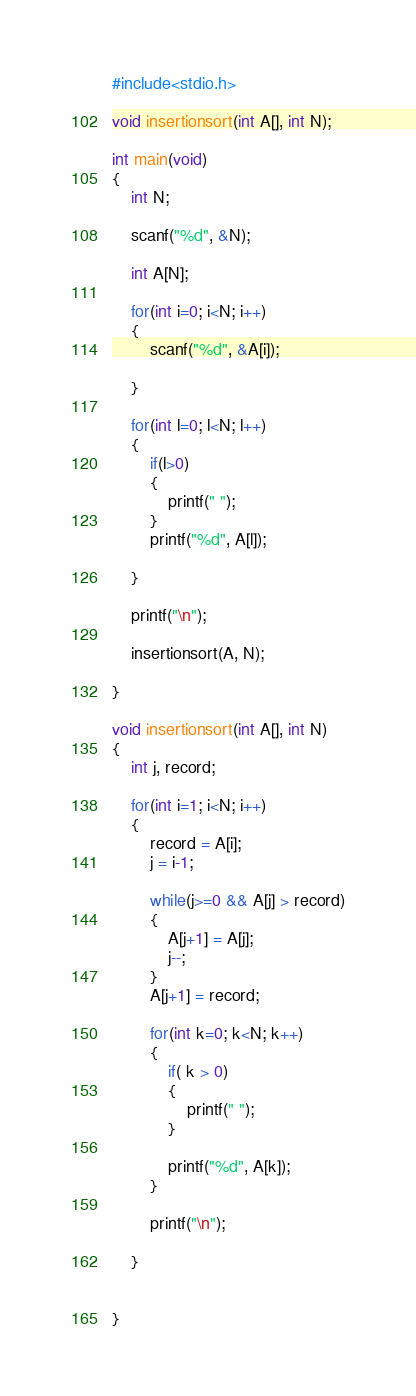Convert code to text. <code><loc_0><loc_0><loc_500><loc_500><_C_>#include<stdio.h>

void insertionsort(int A[], int N);

int main(void)
{
    int N;
    
    scanf("%d", &N);
    
    int A[N];
    
    for(int i=0; i<N; i++)
    {
        scanf("%d", &A[i]);
        
    }
    
    for(int l=0; l<N; l++)
    {
        if(l>0)
        {
            printf(" ");
        }
        printf("%d", A[l]);
        
    }
    
    printf("\n");
    
    insertionsort(A, N);
    
}

void insertionsort(int A[], int N)
{
    int j, record;
    
    for(int i=1; i<N; i++)
    {
        record = A[i];
        j = i-1;
        
        while(j>=0 && A[j] > record)
        {
            A[j+1] = A[j];
            j--;
        }
        A[j+1] = record;
        
        for(int k=0; k<N; k++)
        {
            if( k > 0)
            {
                printf(" ");   
            }
            
            printf("%d", A[k]);
        }
        
        printf("\n");
        
    }
    
    
}
</code> 